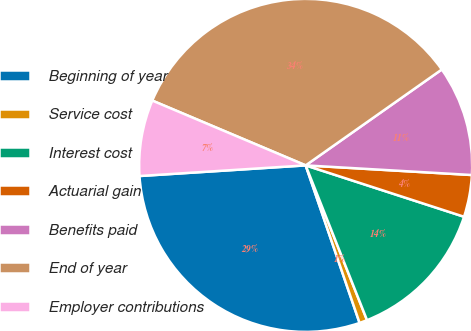<chart> <loc_0><loc_0><loc_500><loc_500><pie_chart><fcel>Beginning of year<fcel>Service cost<fcel>Interest cost<fcel>Actuarial gain<fcel>Benefits paid<fcel>End of year<fcel>Employer contributions<nl><fcel>29.23%<fcel>0.76%<fcel>14.0%<fcel>4.07%<fcel>10.69%<fcel>33.87%<fcel>7.38%<nl></chart> 